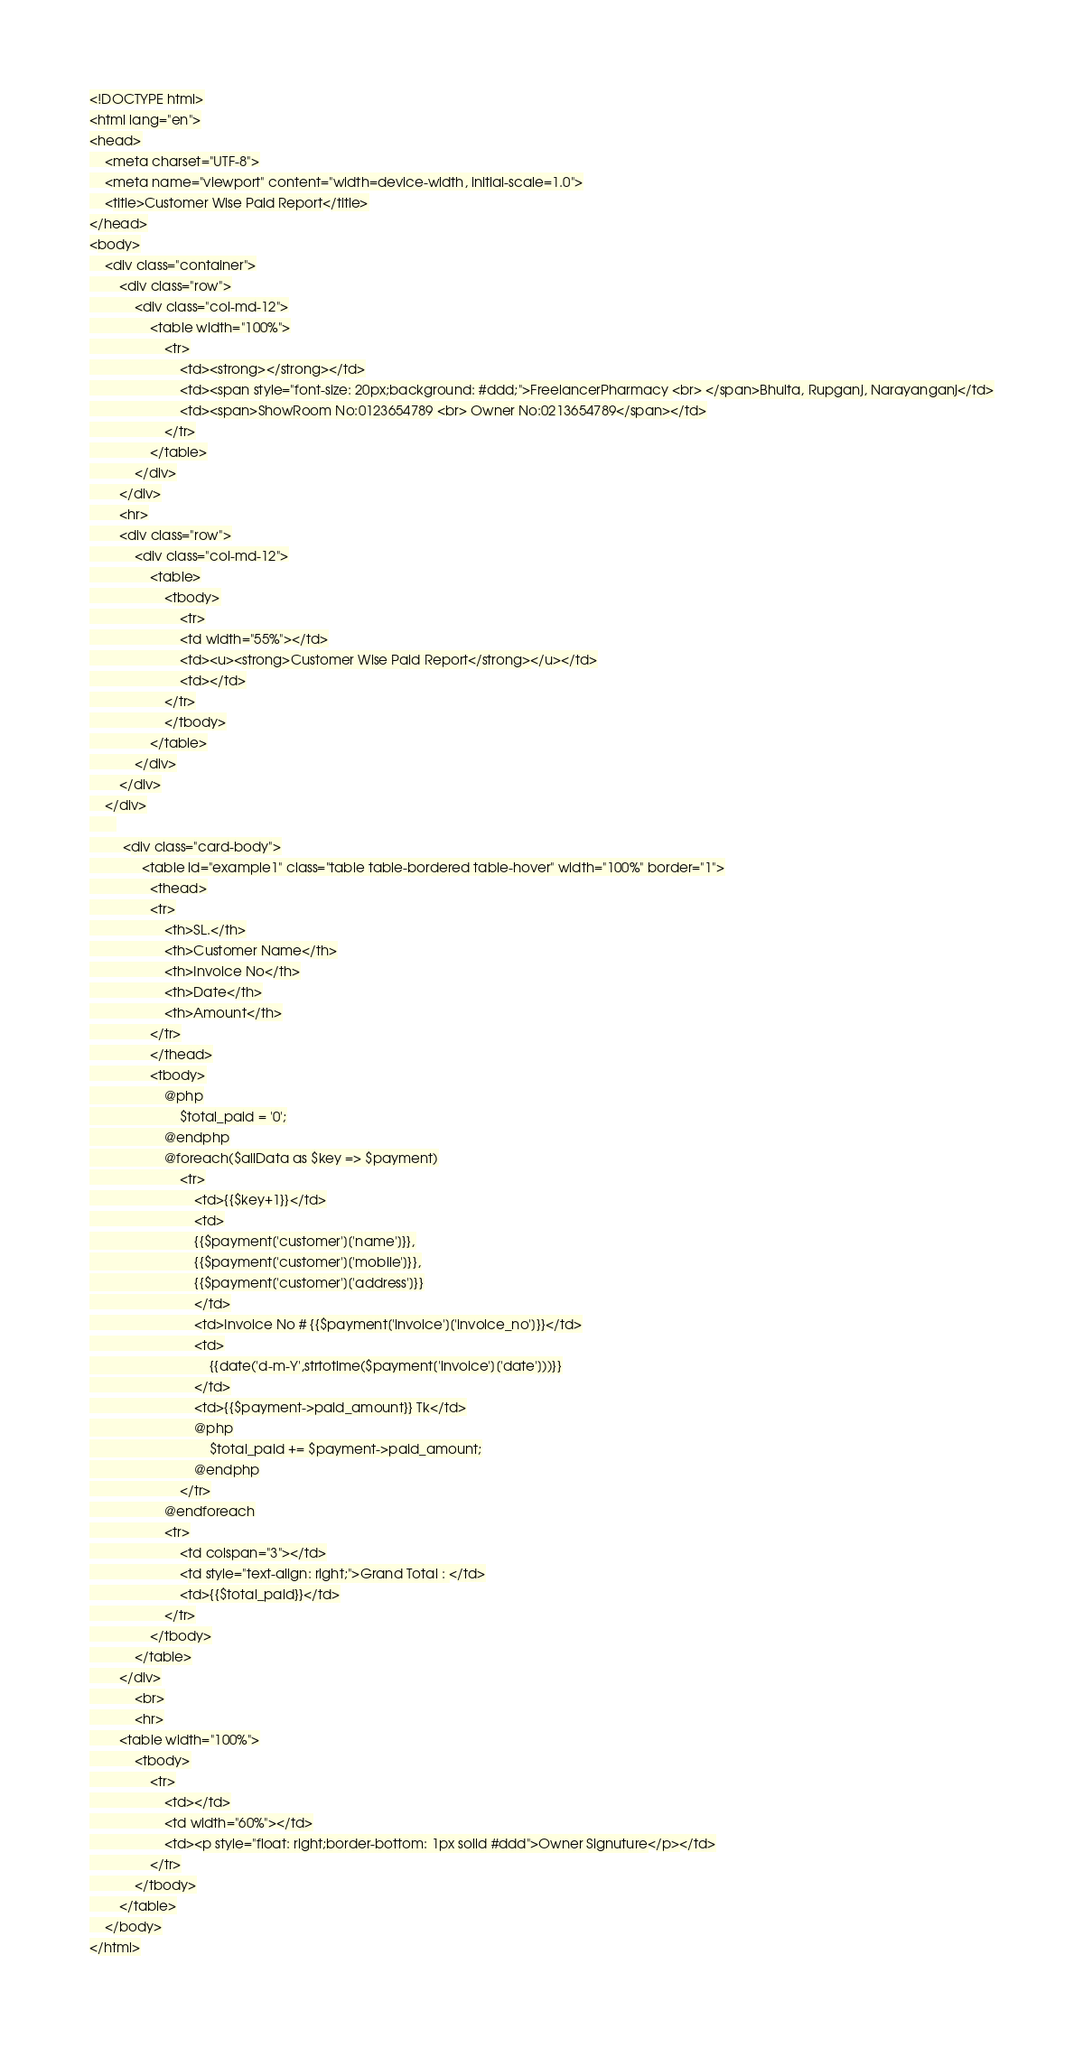<code> <loc_0><loc_0><loc_500><loc_500><_PHP_><!DOCTYPE html>
<html lang="en">
<head>
    <meta charset="UTF-8">
    <meta name="viewport" content="width=device-width, initial-scale=1.0">
    <title>Customer Wise Paid Report</title>
</head>
<body>
    <div class="container">
        <div class="row">
            <div class="col-md-12">
                <table width="100%">
                    <tr>
                        <td><strong></strong></td>
                        <td><span style="font-size: 20px;background: #ddd;">FreelancerPharmacy <br> </span>Bhulta, Rupganj, Narayanganj</td>
                        <td><span>ShowRoom No:0123654789 <br> Owner No:0213654789</span></td>
                    </tr>
                </table>
            </div>
        </div>
        <hr>
        <div class="row">
            <div class="col-md-12">
                <table>
                    <tbody>
                        <tr>
                        <td width="55%"></td>
                        <td><u><strong>Customer Wise Paid Report</strong></u></td>
                        <td></td>
                    </tr>
                    </tbody>
                </table>
            </div>
        </div>
    </div>
       
         <div class="card-body">
              <table id="example1" class="table table-bordered table-hover" width="100%" border="1">
                <thead>
                <tr>
                    <th>SL.</th>
                    <th>Customer Name</th>
                    <th>Invoice No</th>
                    <th>Date</th>
                    <th>Amount</th>
                </tr>
                </thead>
                <tbody>
                    @php
                        $total_paid = '0';
                    @endphp
                    @foreach($allData as $key => $payment)
                        <tr>
                            <td>{{$key+1}}</td>
                            <td>
                            {{$payment['customer']['name']}},
                            {{$payment['customer']['mobile']}},
                            {{$payment['customer']['address']}}
                            </td>
                            <td>Invoice No # {{$payment['invoice']['invoice_no']}}</td>
                            <td>
                                {{date('d-m-Y',strtotime($payment['invoice']['date']))}}
                            </td>
                            <td>{{$payment->paid_amount}} Tk</td>
                            @php
                                $total_paid += $payment->paid_amount;
                            @endphp
                        </tr>
                    @endforeach
                    <tr>
                        <td colspan="3"></td>
                        <td style="text-align: right;">Grand Total : </td>
                        <td>{{$total_paid}}</td>
                    </tr>
                </tbody>
            </table>
        </div>
            <br>
            <hr>
        <table width="100%">
            <tbody>
                <tr>
                    <td></td>
                    <td width="60%"></td>
                    <td><p style="float: right;border-bottom: 1px solid #ddd">Owner Signuture</p></td>
                </tr>
            </tbody>
        </table>
    </body>
</html></code> 